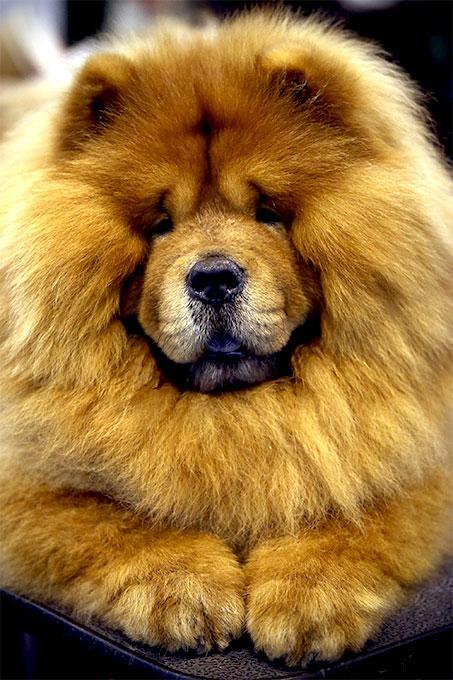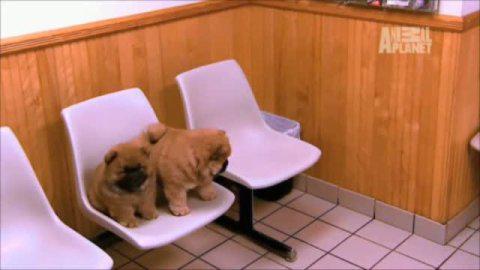The first image is the image on the left, the second image is the image on the right. Examine the images to the left and right. Is the description "There are exactly 3 dogs, and two of them are puppies." accurate? Answer yes or no. Yes. 